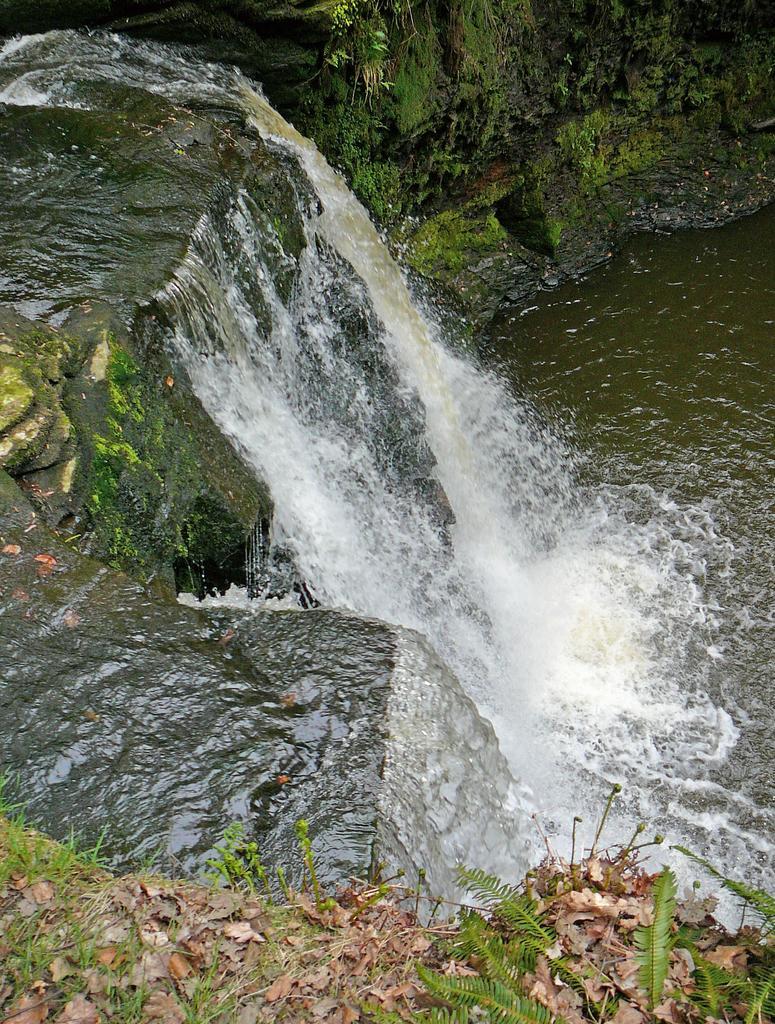In one or two sentences, can you explain what this image depicts? In this image, we can see water flowing from the mountain and there are some dried leaves. 